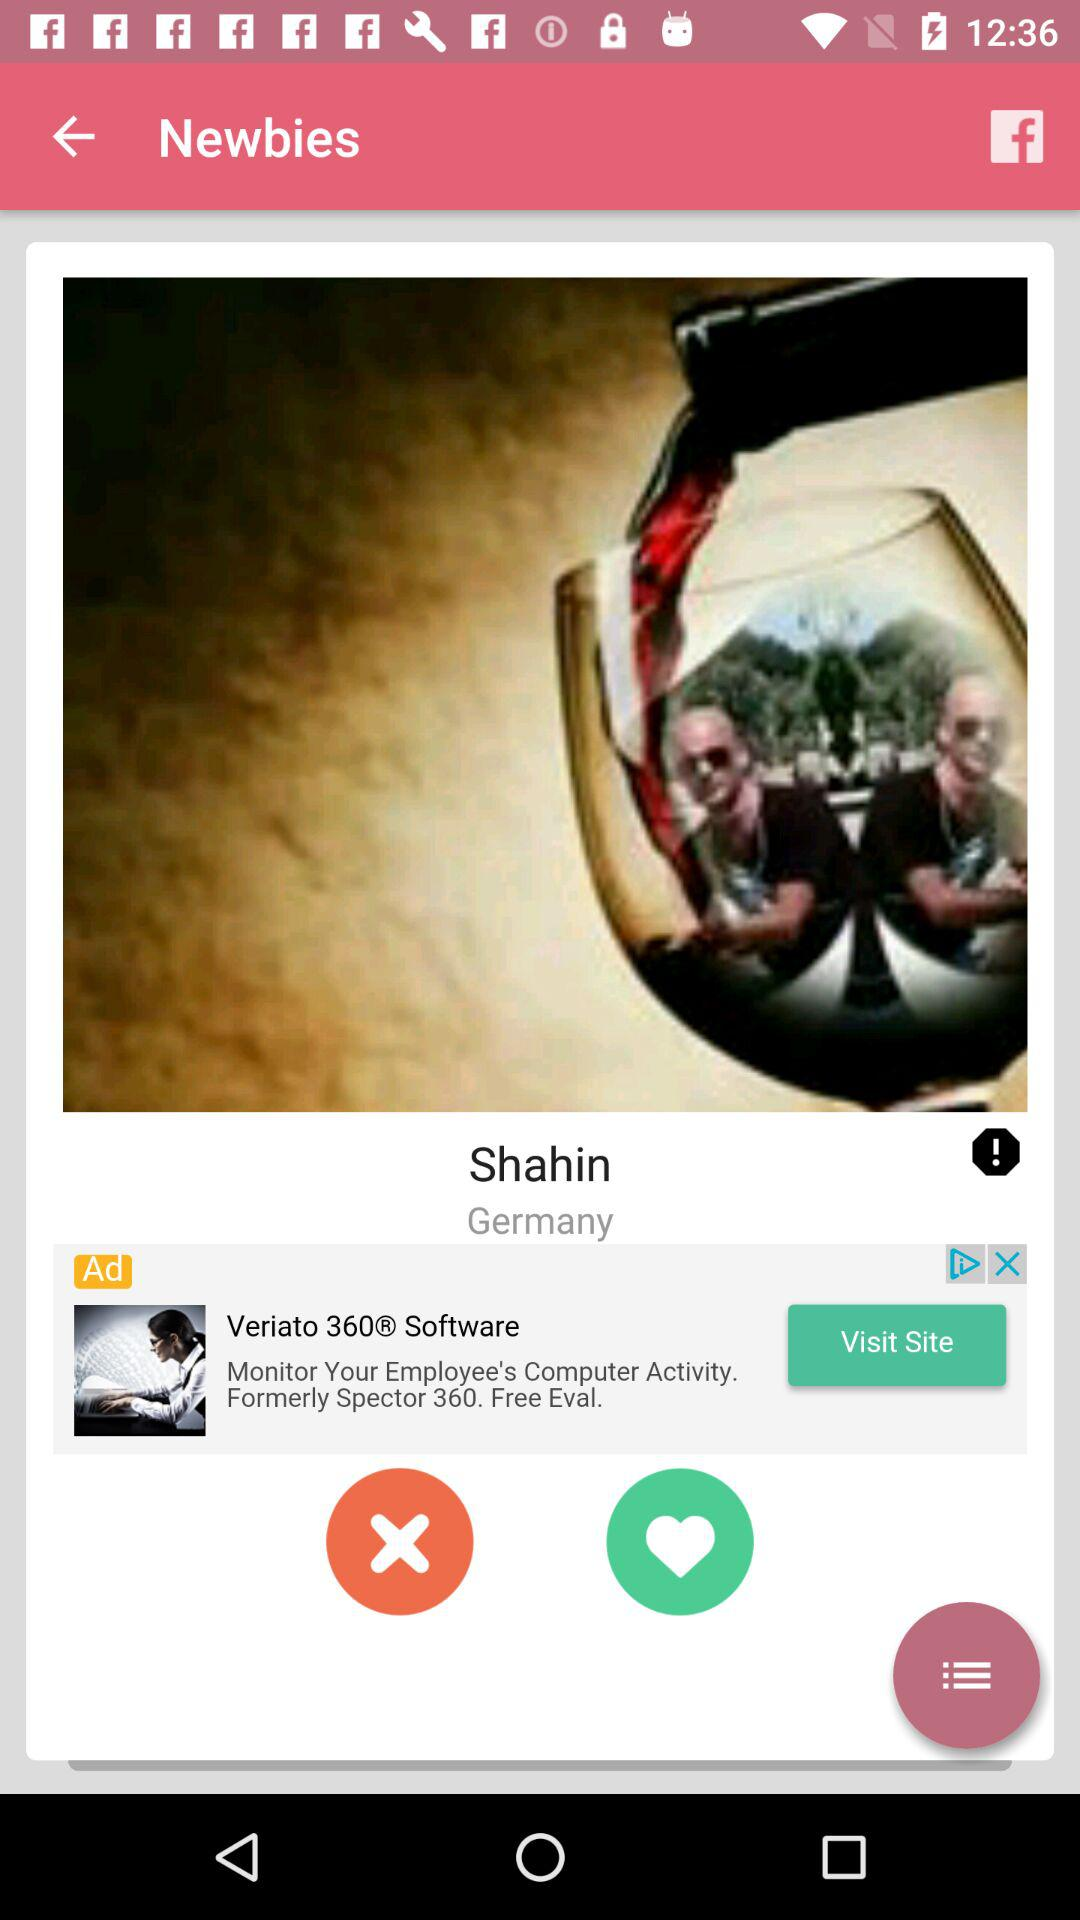What is the name of the person? The name of the person is Shahin. 